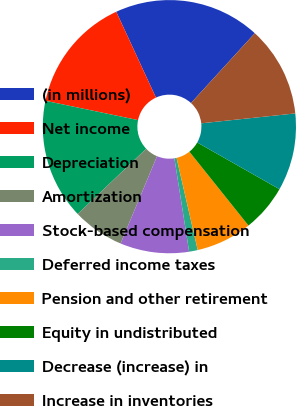Convert chart to OTSL. <chart><loc_0><loc_0><loc_500><loc_500><pie_chart><fcel>(in millions)<fcel>Net income<fcel>Depreciation<fcel>Amortization<fcel>Stock-based compensation<fcel>Deferred income taxes<fcel>Pension and other retirement<fcel>Equity in undistributed<fcel>Decrease (increase) in<fcel>Increase in inventories<nl><fcel>18.68%<fcel>14.83%<fcel>15.38%<fcel>6.59%<fcel>8.79%<fcel>1.1%<fcel>7.14%<fcel>6.04%<fcel>9.89%<fcel>11.54%<nl></chart> 